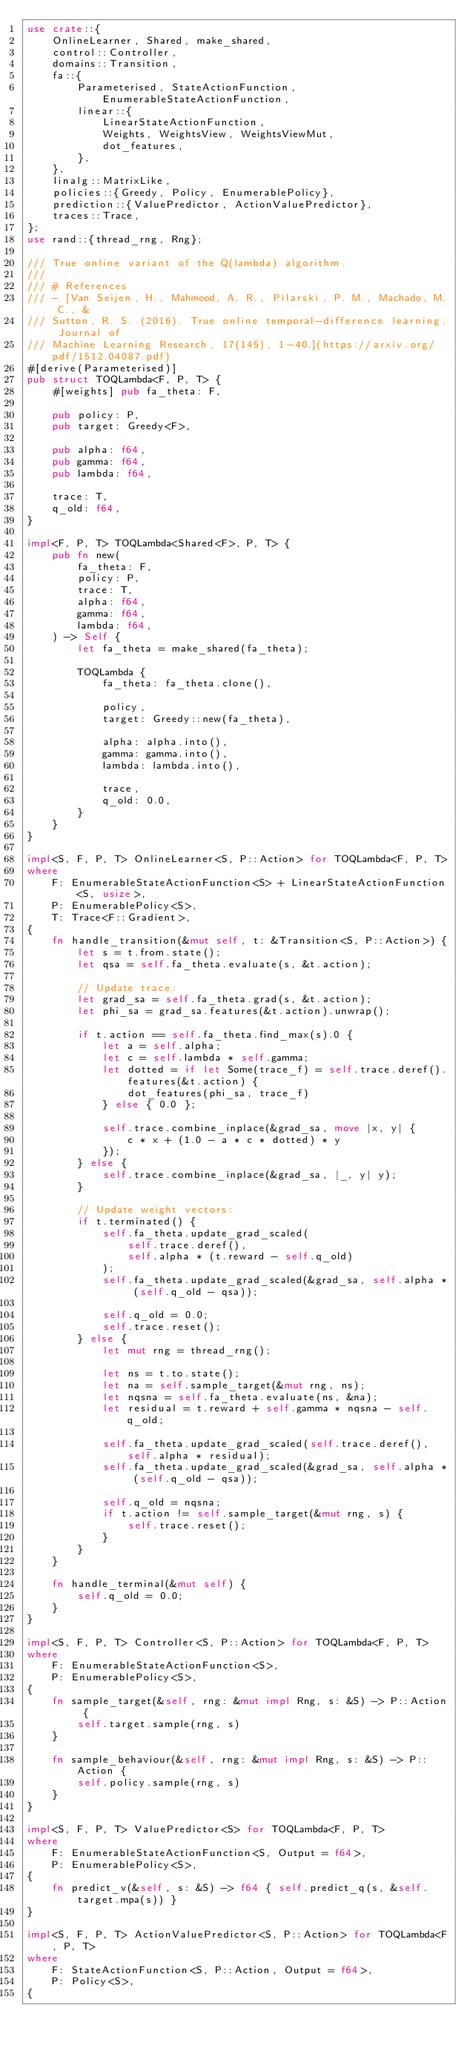<code> <loc_0><loc_0><loc_500><loc_500><_Rust_>use crate::{
    OnlineLearner, Shared, make_shared,
    control::Controller,
    domains::Transition,
    fa::{
        Parameterised, StateActionFunction, EnumerableStateActionFunction,
        linear::{
            LinearStateActionFunction,
            Weights, WeightsView, WeightsViewMut,
            dot_features,
        },
    },
    linalg::MatrixLike,
    policies::{Greedy, Policy, EnumerablePolicy},
    prediction::{ValuePredictor, ActionValuePredictor},
    traces::Trace,
};
use rand::{thread_rng, Rng};

/// True online variant of the Q(lambda) algorithm.
///
/// # References
/// - [Van Seijen, H., Mahmood, A. R., Pilarski, P. M., Machado, M. C., &
/// Sutton, R. S. (2016). True online temporal-difference learning. Journal of
/// Machine Learning Research, 17(145), 1-40.](https://arxiv.org/pdf/1512.04087.pdf)
#[derive(Parameterised)]
pub struct TOQLambda<F, P, T> {
    #[weights] pub fa_theta: F,

    pub policy: P,
    pub target: Greedy<F>,

    pub alpha: f64,
    pub gamma: f64,
    pub lambda: f64,

    trace: T,
    q_old: f64,
}

impl<F, P, T> TOQLambda<Shared<F>, P, T> {
    pub fn new(
        fa_theta: F,
        policy: P,
        trace: T,
        alpha: f64,
        gamma: f64,
        lambda: f64,
    ) -> Self {
        let fa_theta = make_shared(fa_theta);

        TOQLambda {
            fa_theta: fa_theta.clone(),

            policy,
            target: Greedy::new(fa_theta),

            alpha: alpha.into(),
            gamma: gamma.into(),
            lambda: lambda.into(),

            trace,
            q_old: 0.0,
        }
    }
}

impl<S, F, P, T> OnlineLearner<S, P::Action> for TOQLambda<F, P, T>
where
    F: EnumerableStateActionFunction<S> + LinearStateActionFunction<S, usize>,
    P: EnumerablePolicy<S>,
    T: Trace<F::Gradient>,
{
    fn handle_transition(&mut self, t: &Transition<S, P::Action>) {
        let s = t.from.state();
        let qsa = self.fa_theta.evaluate(s, &t.action);

        // Update trace:
        let grad_sa = self.fa_theta.grad(s, &t.action);
        let phi_sa = grad_sa.features(&t.action).unwrap();

        if t.action == self.fa_theta.find_max(s).0 {
            let a = self.alpha;
            let c = self.lambda * self.gamma;
            let dotted = if let Some(trace_f) = self.trace.deref().features(&t.action) {
                dot_features(phi_sa, trace_f)
            } else { 0.0 };

            self.trace.combine_inplace(&grad_sa, move |x, y| {
                c * x + (1.0 - a * c * dotted) * y
            });
        } else {
            self.trace.combine_inplace(&grad_sa, |_, y| y);
        }

        // Update weight vectors:
        if t.terminated() {
            self.fa_theta.update_grad_scaled(
                self.trace.deref(),
                self.alpha * (t.reward - self.q_old)
            );
            self.fa_theta.update_grad_scaled(&grad_sa, self.alpha * (self.q_old - qsa));

            self.q_old = 0.0;
            self.trace.reset();
        } else {
            let mut rng = thread_rng();

            let ns = t.to.state();
            let na = self.sample_target(&mut rng, ns);
            let nqsna = self.fa_theta.evaluate(ns, &na);
            let residual = t.reward + self.gamma * nqsna - self.q_old;

            self.fa_theta.update_grad_scaled(self.trace.deref(), self.alpha * residual);
            self.fa_theta.update_grad_scaled(&grad_sa, self.alpha * (self.q_old - qsa));

            self.q_old = nqsna;
            if t.action != self.sample_target(&mut rng, s) {
                self.trace.reset();
            }
        }
    }

    fn handle_terminal(&mut self) {
        self.q_old = 0.0;
    }
}

impl<S, F, P, T> Controller<S, P::Action> for TOQLambda<F, P, T>
where
    F: EnumerableStateActionFunction<S>,
    P: EnumerablePolicy<S>,
{
    fn sample_target(&self, rng: &mut impl Rng, s: &S) -> P::Action {
        self.target.sample(rng, s)
    }

    fn sample_behaviour(&self, rng: &mut impl Rng, s: &S) -> P::Action {
        self.policy.sample(rng, s)
    }
}

impl<S, F, P, T> ValuePredictor<S> for TOQLambda<F, P, T>
where
    F: EnumerableStateActionFunction<S, Output = f64>,
    P: EnumerablePolicy<S>,
{
    fn predict_v(&self, s: &S) -> f64 { self.predict_q(s, &self.target.mpa(s)) }
}

impl<S, F, P, T> ActionValuePredictor<S, P::Action> for TOQLambda<F, P, T>
where
    F: StateActionFunction<S, P::Action, Output = f64>,
    P: Policy<S>,
{</code> 